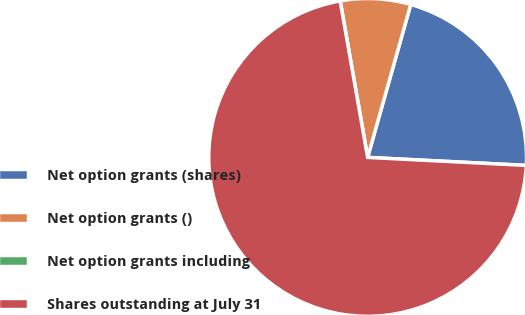Convert chart. <chart><loc_0><loc_0><loc_500><loc_500><pie_chart><fcel>Net option grants (shares)<fcel>Net option grants ()<fcel>Net option grants including<fcel>Shares outstanding at July 31<nl><fcel>21.43%<fcel>7.14%<fcel>0.0%<fcel>71.43%<nl></chart> 